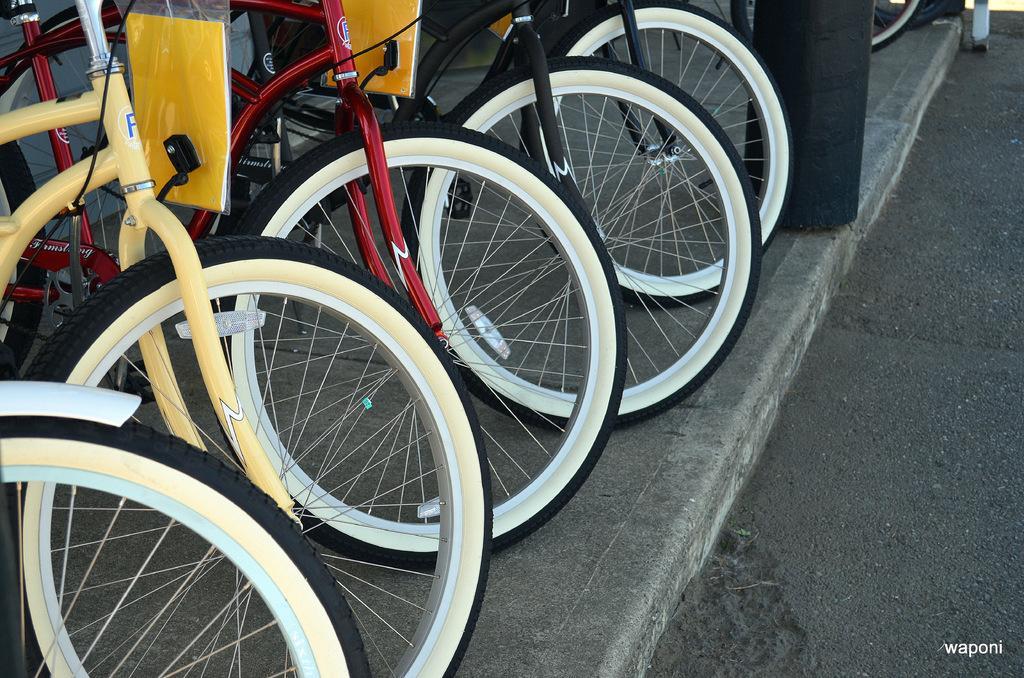Describe this image in one or two sentences. In the center of the image we can see a few cycles with multi colors. And we can see two plastic covers with yellow color objects in it. In the background there is a black color object and a few other objects. At the bottom right side of the image, we can see some text. 